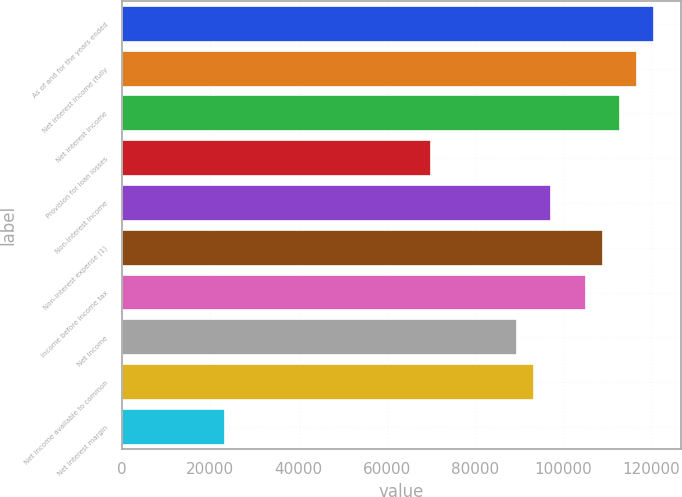Convert chart. <chart><loc_0><loc_0><loc_500><loc_500><bar_chart><fcel>As of and for the years ended<fcel>Net interest income (fully<fcel>Net interest income<fcel>Provision for loan losses<fcel>Non-interest income<fcel>Non-interest expense (1)<fcel>Income before income tax<fcel>Net income<fcel>Net income available to common<fcel>Net interest margin<nl><fcel>120735<fcel>116841<fcel>112946<fcel>70104.5<fcel>97367.3<fcel>109051<fcel>105157<fcel>89577.9<fcel>93472.6<fcel>23368.2<nl></chart> 